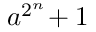<formula> <loc_0><loc_0><loc_500><loc_500>a ^ { 2 ^ { n } } \, + 1</formula> 